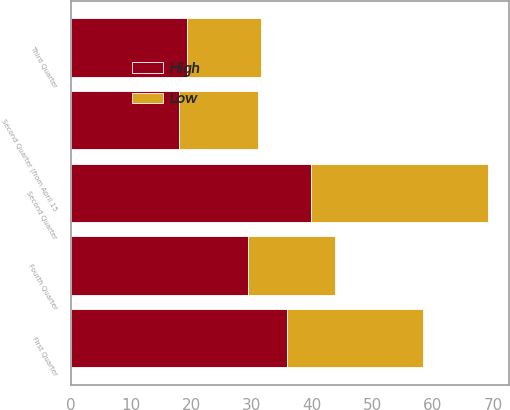Convert chart. <chart><loc_0><loc_0><loc_500><loc_500><stacked_bar_chart><ecel><fcel>Second Quarter (from April 15<fcel>Third Quarter<fcel>Fourth Quarter<fcel>First Quarter<fcel>Second Quarter<nl><fcel>High<fcel>17.92<fcel>19.24<fcel>29.42<fcel>35.86<fcel>39.75<nl><fcel>Low<fcel>13.01<fcel>12.28<fcel>14.32<fcel>22.58<fcel>29.36<nl></chart> 